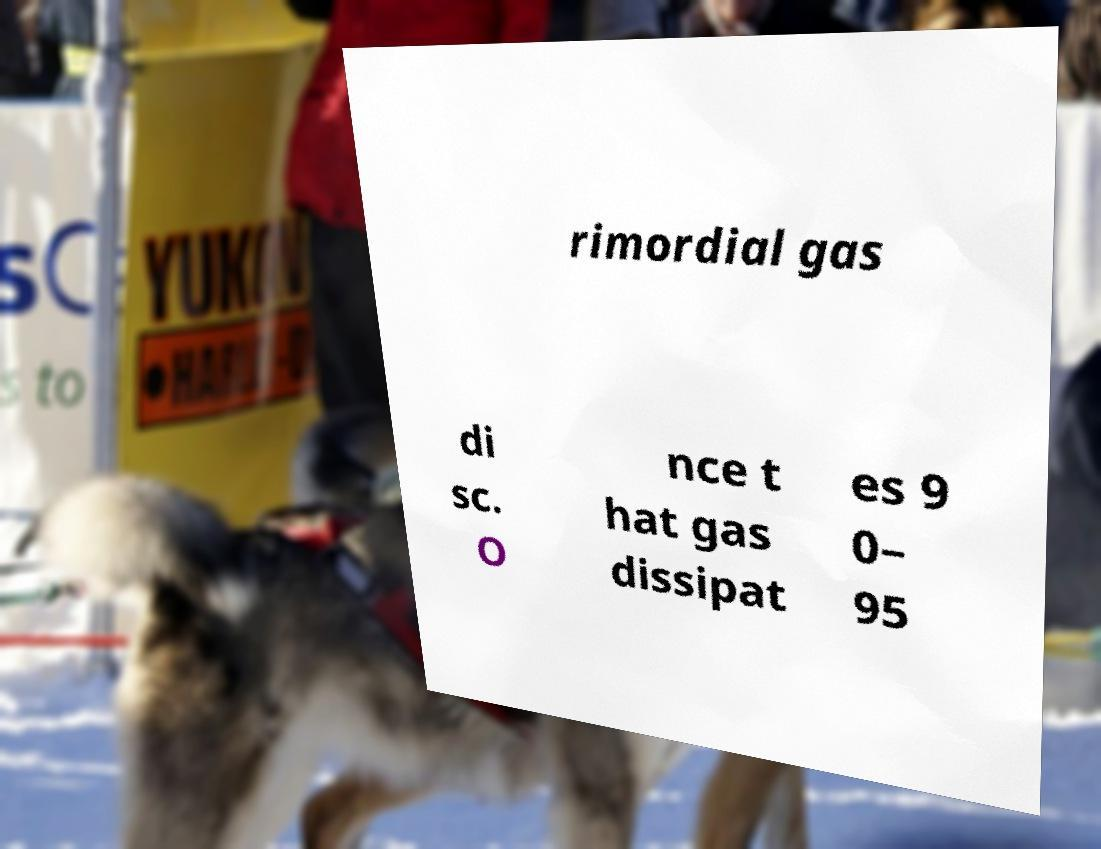Please read and relay the text visible in this image. What does it say? rimordial gas di sc. O nce t hat gas dissipat es 9 0– 95 